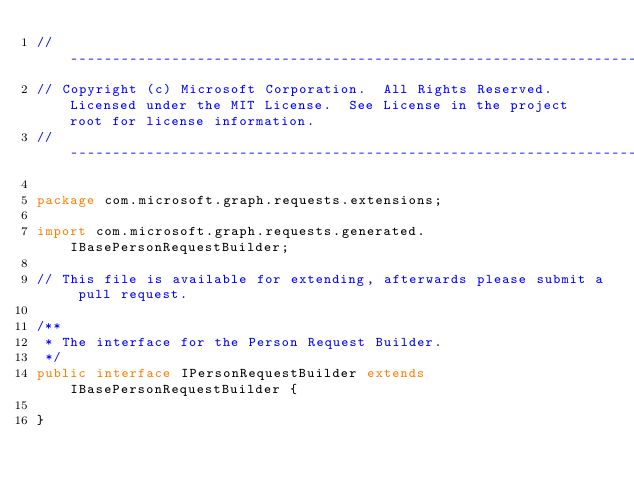Convert code to text. <code><loc_0><loc_0><loc_500><loc_500><_Java_>// ------------------------------------------------------------------------------
// Copyright (c) Microsoft Corporation.  All Rights Reserved.  Licensed under the MIT License.  See License in the project root for license information.
// ------------------------------------------------------------------------------

package com.microsoft.graph.requests.extensions;

import com.microsoft.graph.requests.generated.IBasePersonRequestBuilder;

// This file is available for extending, afterwards please submit a pull request.

/**
 * The interface for the Person Request Builder.
 */
public interface IPersonRequestBuilder extends IBasePersonRequestBuilder {

}
</code> 